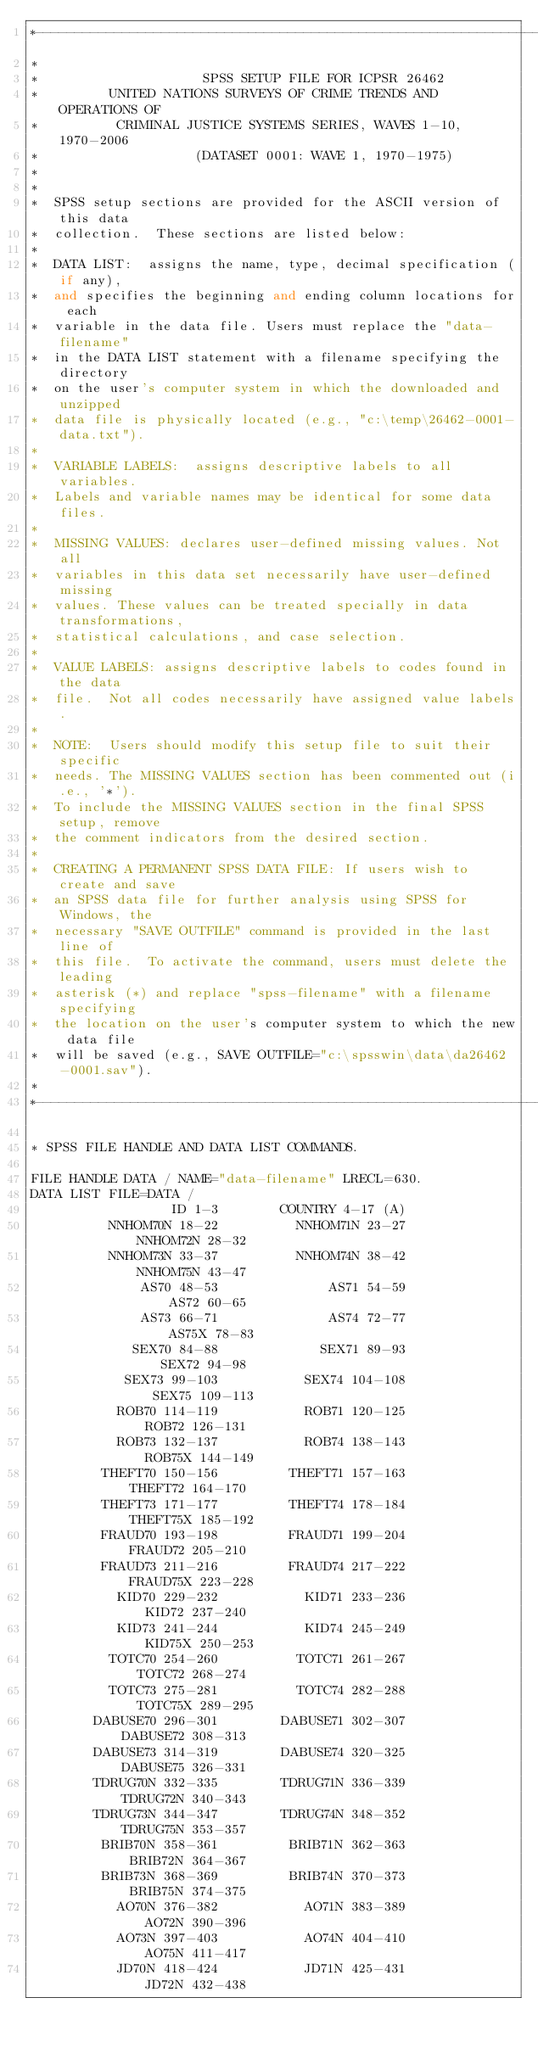<code> <loc_0><loc_0><loc_500><loc_500><_Scheme_>*-------------------------------------------------------------------------*
*                                                                          
*                     SPSS SETUP FILE FOR ICPSR 26462
*         UNITED NATIONS SURVEYS OF CRIME TRENDS AND OPERATIONS OF
*          CRIMINAL JUSTICE SYSTEMS SERIES, WAVES 1-10, 1970-2006
*                    (DATASET 0001: WAVE 1, 1970-1975)
* 
*
*  SPSS setup sections are provided for the ASCII version of this data
*  collection.  These sections are listed below:
*
*  DATA LIST:  assigns the name, type, decimal specification (if any),
*  and specifies the beginning and ending column locations for each
*  variable in the data file. Users must replace the "data-filename"
*  in the DATA LIST statement with a filename specifying the directory
*  on the user's computer system in which the downloaded and unzipped
*  data file is physically located (e.g., "c:\temp\26462-0001-data.txt").
*
*  VARIABLE LABELS:  assigns descriptive labels to all variables.
*  Labels and variable names may be identical for some data files.
*
*  MISSING VALUES: declares user-defined missing values. Not all
*  variables in this data set necessarily have user-defined missing
*  values. These values can be treated specially in data transformations,
*  statistical calculations, and case selection.
*
*  VALUE LABELS: assigns descriptive labels to codes found in the data
*  file.  Not all codes necessarily have assigned value labels.
*
*  NOTE:  Users should modify this setup file to suit their specific 
*  needs. The MISSING VALUES section has been commented out (i.e., '*').
*  To include the MISSING VALUES section in the final SPSS setup, remove 
*  the comment indicators from the desired section.
*
*  CREATING A PERMANENT SPSS DATA FILE: If users wish to create and save
*  an SPSS data file for further analysis using SPSS for Windows, the
*  necessary "SAVE OUTFILE" command is provided in the last line of
*  this file.  To activate the command, users must delete the leading
*  asterisk (*) and replace "spss-filename" with a filename specifying
*  the location on the user's computer system to which the new data file
*  will be saved (e.g., SAVE OUTFILE="c:\spsswin\data\da26462-0001.sav").
*
*-------------------------------------------------------------------------.

* SPSS FILE HANDLE AND DATA LIST COMMANDS.

FILE HANDLE DATA / NAME="data-filename" LRECL=630.
DATA LIST FILE=DATA /
                  ID 1-3        COUNTRY 4-17 (A)
          NNHOM70N 18-22          NNHOM71N 23-27          NNHOM72N 28-32
          NNHOM73N 33-37          NNHOM74N 38-42          NNHOM75N 43-47
              AS70 48-53              AS71 54-59              AS72 60-65
              AS73 66-71              AS74 72-77             AS75X 78-83
             SEX70 84-88             SEX71 89-93             SEX72 94-98
            SEX73 99-103           SEX74 104-108           SEX75 109-113
           ROB70 114-119           ROB71 120-125           ROB72 126-131
           ROB73 132-137           ROB74 138-143          ROB75X 144-149
         THEFT70 150-156         THEFT71 157-163         THEFT72 164-170
         THEFT73 171-177         THEFT74 178-184        THEFT75X 185-192
         FRAUD70 193-198         FRAUD71 199-204         FRAUD72 205-210
         FRAUD73 211-216         FRAUD74 217-222        FRAUD75X 223-228
           KID70 229-232           KID71 233-236           KID72 237-240
           KID73 241-244           KID74 245-249          KID75X 250-253
          TOTC70 254-260          TOTC71 261-267          TOTC72 268-274
          TOTC73 275-281          TOTC74 282-288         TOTC75X 289-295
        DABUSE70 296-301        DABUSE71 302-307        DABUSE72 308-313
        DABUSE73 314-319        DABUSE74 320-325        DABUSE75 326-331
        TDRUG70N 332-335        TDRUG71N 336-339        TDRUG72N 340-343
        TDRUG73N 344-347        TDRUG74N 348-352        TDRUG75N 353-357
         BRIB70N 358-361         BRIB71N 362-363         BRIB72N 364-367
         BRIB73N 368-369         BRIB74N 370-373         BRIB75N 374-375
           AO70N 376-382           AO71N 383-389           AO72N 390-396
           AO73N 397-403           AO74N 404-410           AO75N 411-417
           JD70N 418-424           JD71N 425-431           JD72N 432-438</code> 